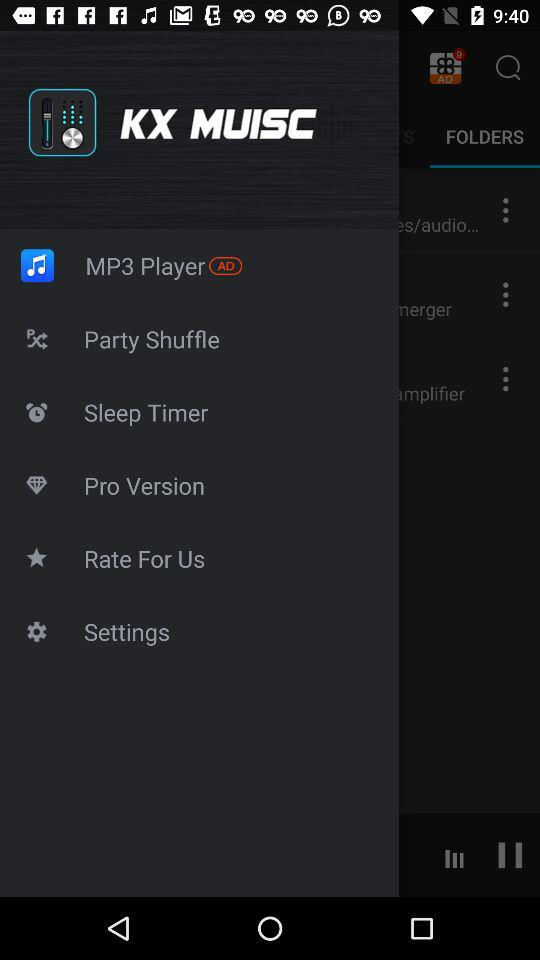What is the name of the artist for the song that is currently playing?
Answer the question using a single word or phrase. Unknown artist 